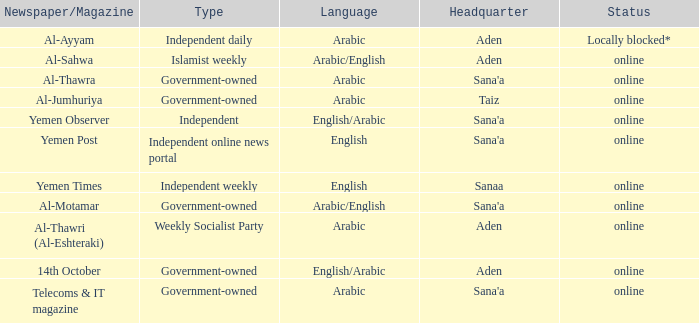What is the main office location for an independent online news portal when the language used is english? Sana'a. 